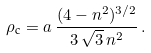Convert formula to latex. <formula><loc_0><loc_0><loc_500><loc_500>\rho _ { \text {c} } = a \, \frac { ( 4 - n ^ { 2 } ) ^ { 3 / 2 } } { 3 \, \sqrt { 3 } \, n ^ { 2 } } \, .</formula> 